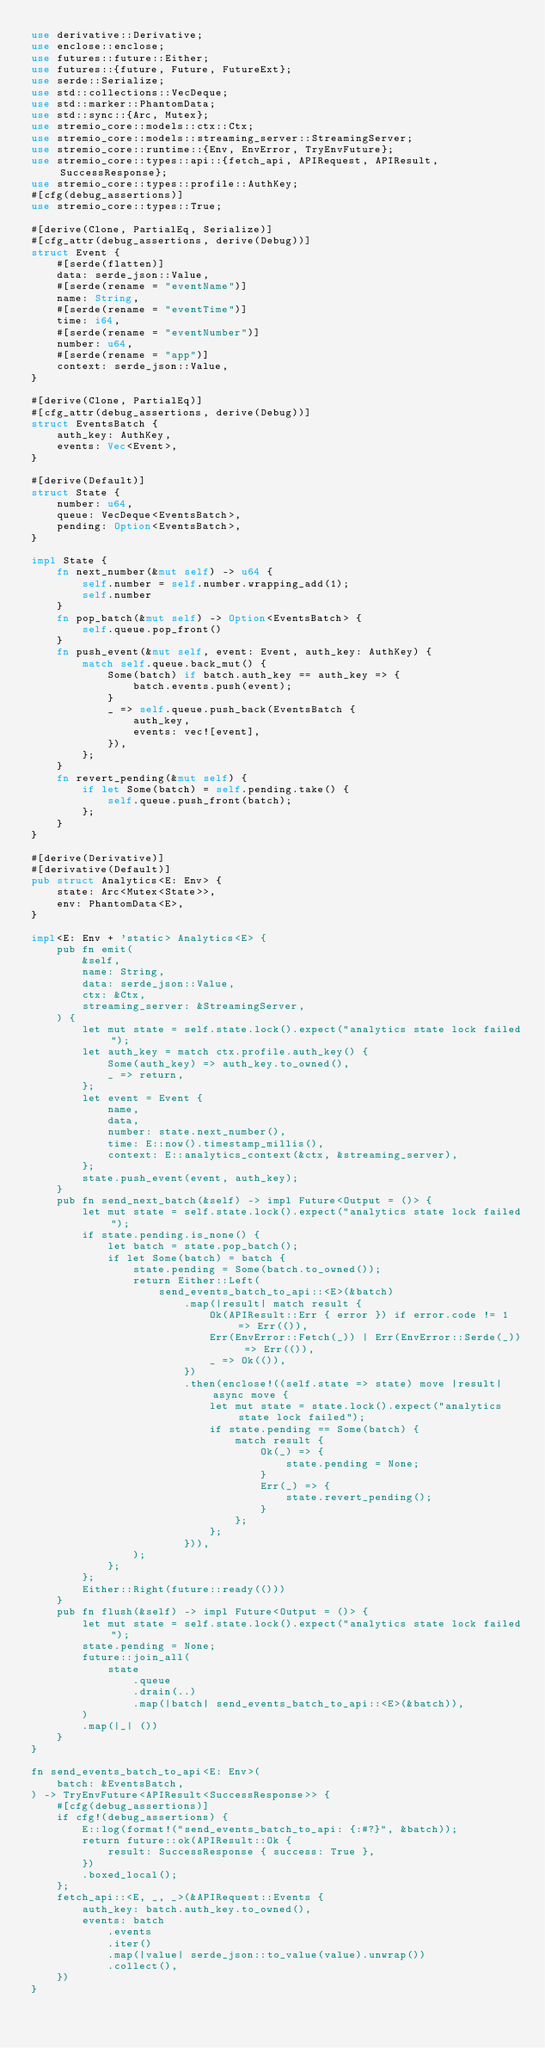Convert code to text. <code><loc_0><loc_0><loc_500><loc_500><_Rust_>use derivative::Derivative;
use enclose::enclose;
use futures::future::Either;
use futures::{future, Future, FutureExt};
use serde::Serialize;
use std::collections::VecDeque;
use std::marker::PhantomData;
use std::sync::{Arc, Mutex};
use stremio_core::models::ctx::Ctx;
use stremio_core::models::streaming_server::StreamingServer;
use stremio_core::runtime::{Env, EnvError, TryEnvFuture};
use stremio_core::types::api::{fetch_api, APIRequest, APIResult, SuccessResponse};
use stremio_core::types::profile::AuthKey;
#[cfg(debug_assertions)]
use stremio_core::types::True;

#[derive(Clone, PartialEq, Serialize)]
#[cfg_attr(debug_assertions, derive(Debug))]
struct Event {
    #[serde(flatten)]
    data: serde_json::Value,
    #[serde(rename = "eventName")]
    name: String,
    #[serde(rename = "eventTime")]
    time: i64,
    #[serde(rename = "eventNumber")]
    number: u64,
    #[serde(rename = "app")]
    context: serde_json::Value,
}

#[derive(Clone, PartialEq)]
#[cfg_attr(debug_assertions, derive(Debug))]
struct EventsBatch {
    auth_key: AuthKey,
    events: Vec<Event>,
}

#[derive(Default)]
struct State {
    number: u64,
    queue: VecDeque<EventsBatch>,
    pending: Option<EventsBatch>,
}

impl State {
    fn next_number(&mut self) -> u64 {
        self.number = self.number.wrapping_add(1);
        self.number
    }
    fn pop_batch(&mut self) -> Option<EventsBatch> {
        self.queue.pop_front()
    }
    fn push_event(&mut self, event: Event, auth_key: AuthKey) {
        match self.queue.back_mut() {
            Some(batch) if batch.auth_key == auth_key => {
                batch.events.push(event);
            }
            _ => self.queue.push_back(EventsBatch {
                auth_key,
                events: vec![event],
            }),
        };
    }
    fn revert_pending(&mut self) {
        if let Some(batch) = self.pending.take() {
            self.queue.push_front(batch);
        };
    }
}

#[derive(Derivative)]
#[derivative(Default)]
pub struct Analytics<E: Env> {
    state: Arc<Mutex<State>>,
    env: PhantomData<E>,
}

impl<E: Env + 'static> Analytics<E> {
    pub fn emit(
        &self,
        name: String,
        data: serde_json::Value,
        ctx: &Ctx,
        streaming_server: &StreamingServer,
    ) {
        let mut state = self.state.lock().expect("analytics state lock failed");
        let auth_key = match ctx.profile.auth_key() {
            Some(auth_key) => auth_key.to_owned(),
            _ => return,
        };
        let event = Event {
            name,
            data,
            number: state.next_number(),
            time: E::now().timestamp_millis(),
            context: E::analytics_context(&ctx, &streaming_server),
        };
        state.push_event(event, auth_key);
    }
    pub fn send_next_batch(&self) -> impl Future<Output = ()> {
        let mut state = self.state.lock().expect("analytics state lock failed");
        if state.pending.is_none() {
            let batch = state.pop_batch();
            if let Some(batch) = batch {
                state.pending = Some(batch.to_owned());
                return Either::Left(
                    send_events_batch_to_api::<E>(&batch)
                        .map(|result| match result {
                            Ok(APIResult::Err { error }) if error.code != 1 => Err(()),
                            Err(EnvError::Fetch(_)) | Err(EnvError::Serde(_)) => Err(()),
                            _ => Ok(()),
                        })
                        .then(enclose!((self.state => state) move |result| async move {
                            let mut state = state.lock().expect("analytics state lock failed");
                            if state.pending == Some(batch) {
                                match result {
                                    Ok(_) => {
                                        state.pending = None;
                                    }
                                    Err(_) => {
                                        state.revert_pending();
                                    }
                                };
                            };
                        })),
                );
            };
        };
        Either::Right(future::ready(()))
    }
    pub fn flush(&self) -> impl Future<Output = ()> {
        let mut state = self.state.lock().expect("analytics state lock failed");
        state.pending = None;
        future::join_all(
            state
                .queue
                .drain(..)
                .map(|batch| send_events_batch_to_api::<E>(&batch)),
        )
        .map(|_| ())
    }
}

fn send_events_batch_to_api<E: Env>(
    batch: &EventsBatch,
) -> TryEnvFuture<APIResult<SuccessResponse>> {
    #[cfg(debug_assertions)]
    if cfg!(debug_assertions) {
        E::log(format!("send_events_batch_to_api: {:#?}", &batch));
        return future::ok(APIResult::Ok {
            result: SuccessResponse { success: True },
        })
        .boxed_local();
    };
    fetch_api::<E, _, _>(&APIRequest::Events {
        auth_key: batch.auth_key.to_owned(),
        events: batch
            .events
            .iter()
            .map(|value| serde_json::to_value(value).unwrap())
            .collect(),
    })
}
</code> 